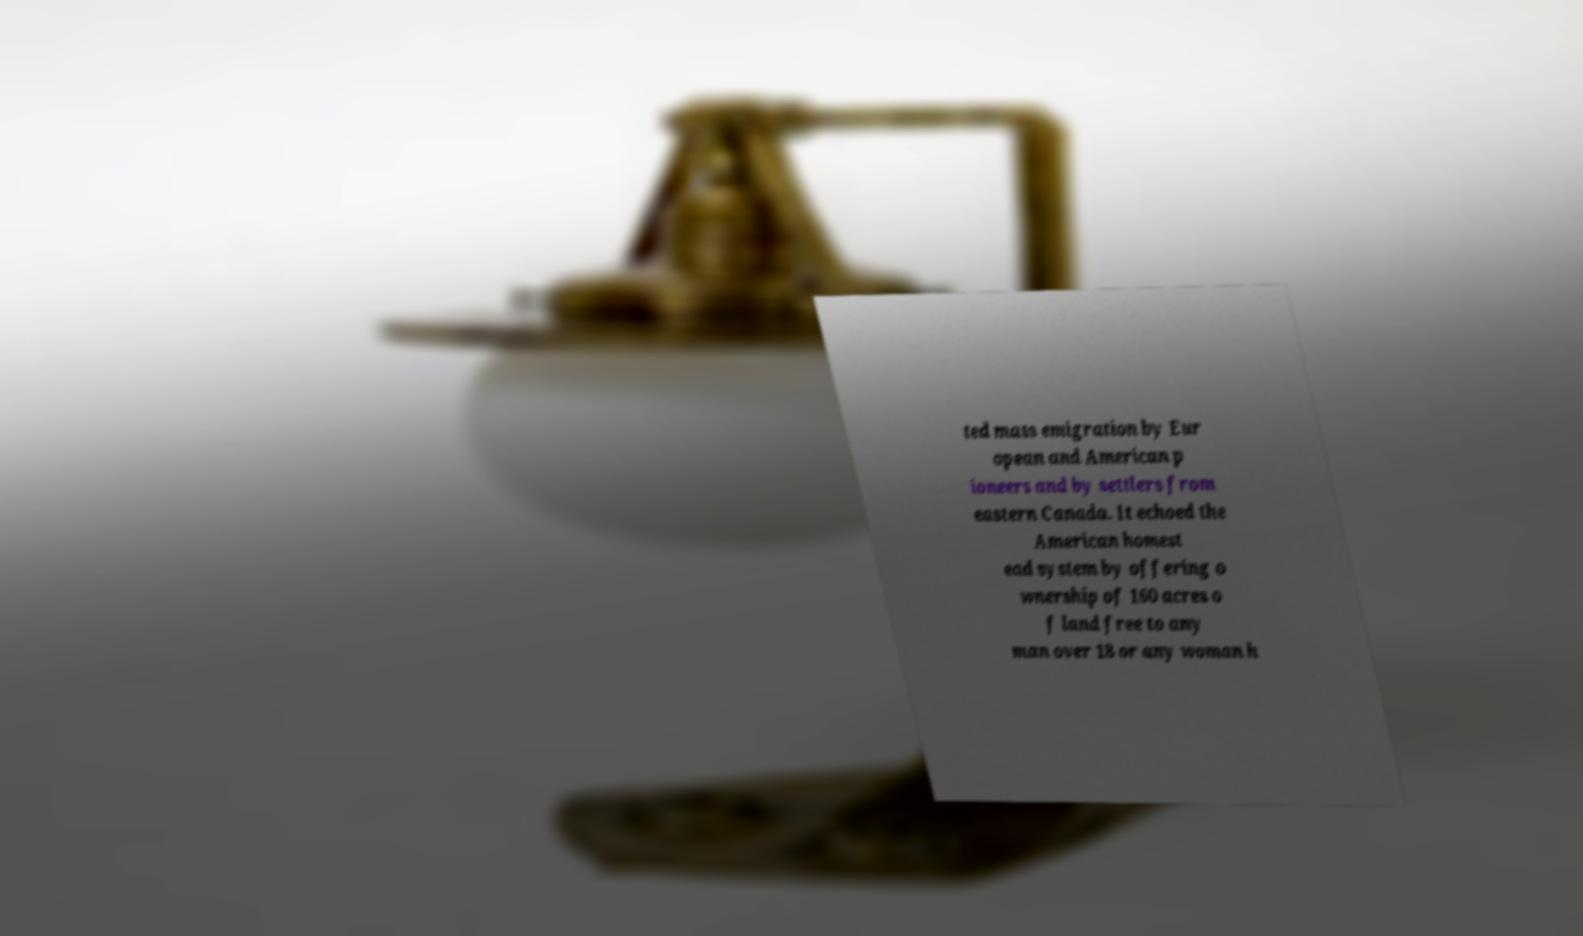Could you extract and type out the text from this image? ted mass emigration by Eur opean and American p ioneers and by settlers from eastern Canada. It echoed the American homest ead system by offering o wnership of 160 acres o f land free to any man over 18 or any woman h 